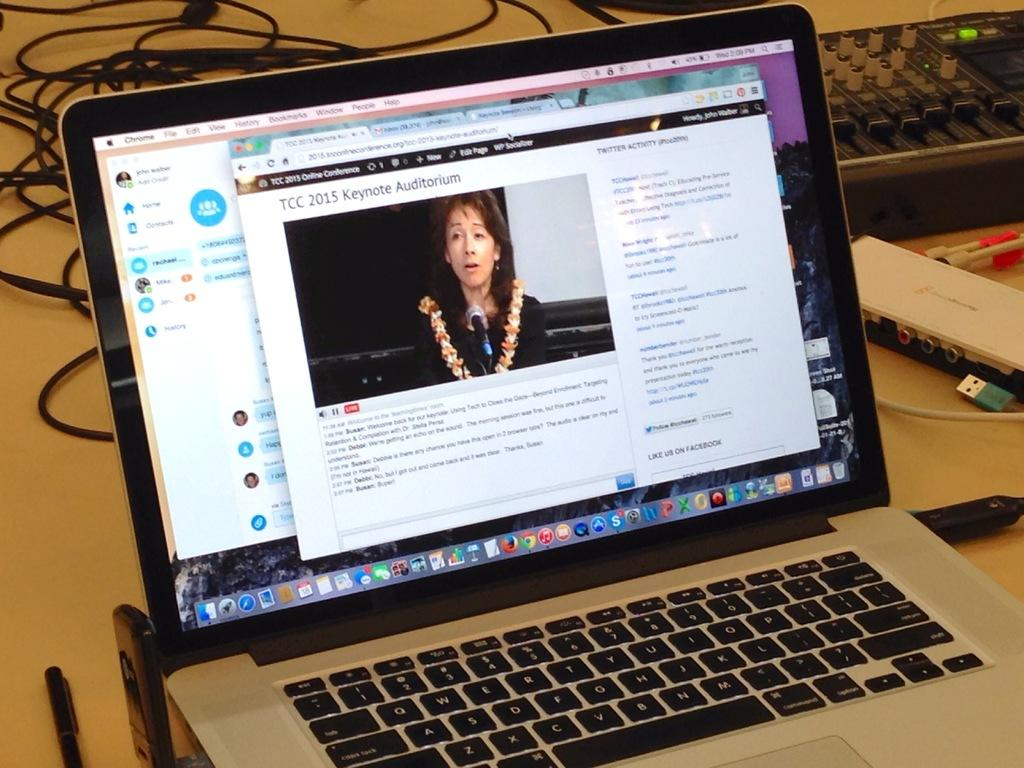What type of furniture is present in the image? There is a table in the image. What is on top of the table? The table has many cores on it, a laptop, and a pen. Can you describe the electronic device on the table? There is a laptop on the table. What other item can be seen on the table? There is a pen on the table. Are there any other items visible on the table? Yes, there are additional items on the table. How many friends are sitting around the table in the image? There is no mention of friends or people sitting around the table in the image. What type of tail is visible on the laptop in the image? There is no tail present on the laptop or any other object in the image. 